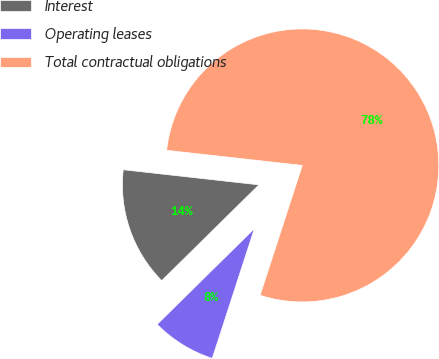Convert chart. <chart><loc_0><loc_0><loc_500><loc_500><pie_chart><fcel>Interest<fcel>Operating leases<fcel>Total contractual obligations<nl><fcel>14.15%<fcel>7.62%<fcel>78.24%<nl></chart> 